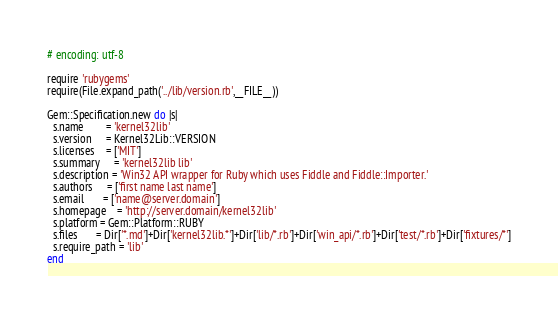Convert code to text. <code><loc_0><loc_0><loc_500><loc_500><_Ruby_># encoding: utf-8

require 'rubygems'
require(File.expand_path('../lib/version.rb',__FILE__))

Gem::Specification.new do |s|
  s.name        = 'kernel32lib'
  s.version     = Kernel32Lib::VERSION
  s.licenses    = ['MIT']
  s.summary     = 'kernel32lib lib'
  s.description = 'Win32 API wrapper for Ruby which uses Fiddle and Fiddle::Importer.'
  s.authors     = ['first name last name']
  s.email       = ['name@server.domain']
  s.homepage    = 'http://server.domain/kernel32lib'
  s.platform = Gem::Platform::RUBY
  s.files       = Dir['*.md']+Dir['kernel32lib.*']+Dir['lib/*.rb']+Dir['win_api/*.rb']+Dir['test/*.rb']+Dir['fixtures/*']
  s.require_path = 'lib'
end
</code> 